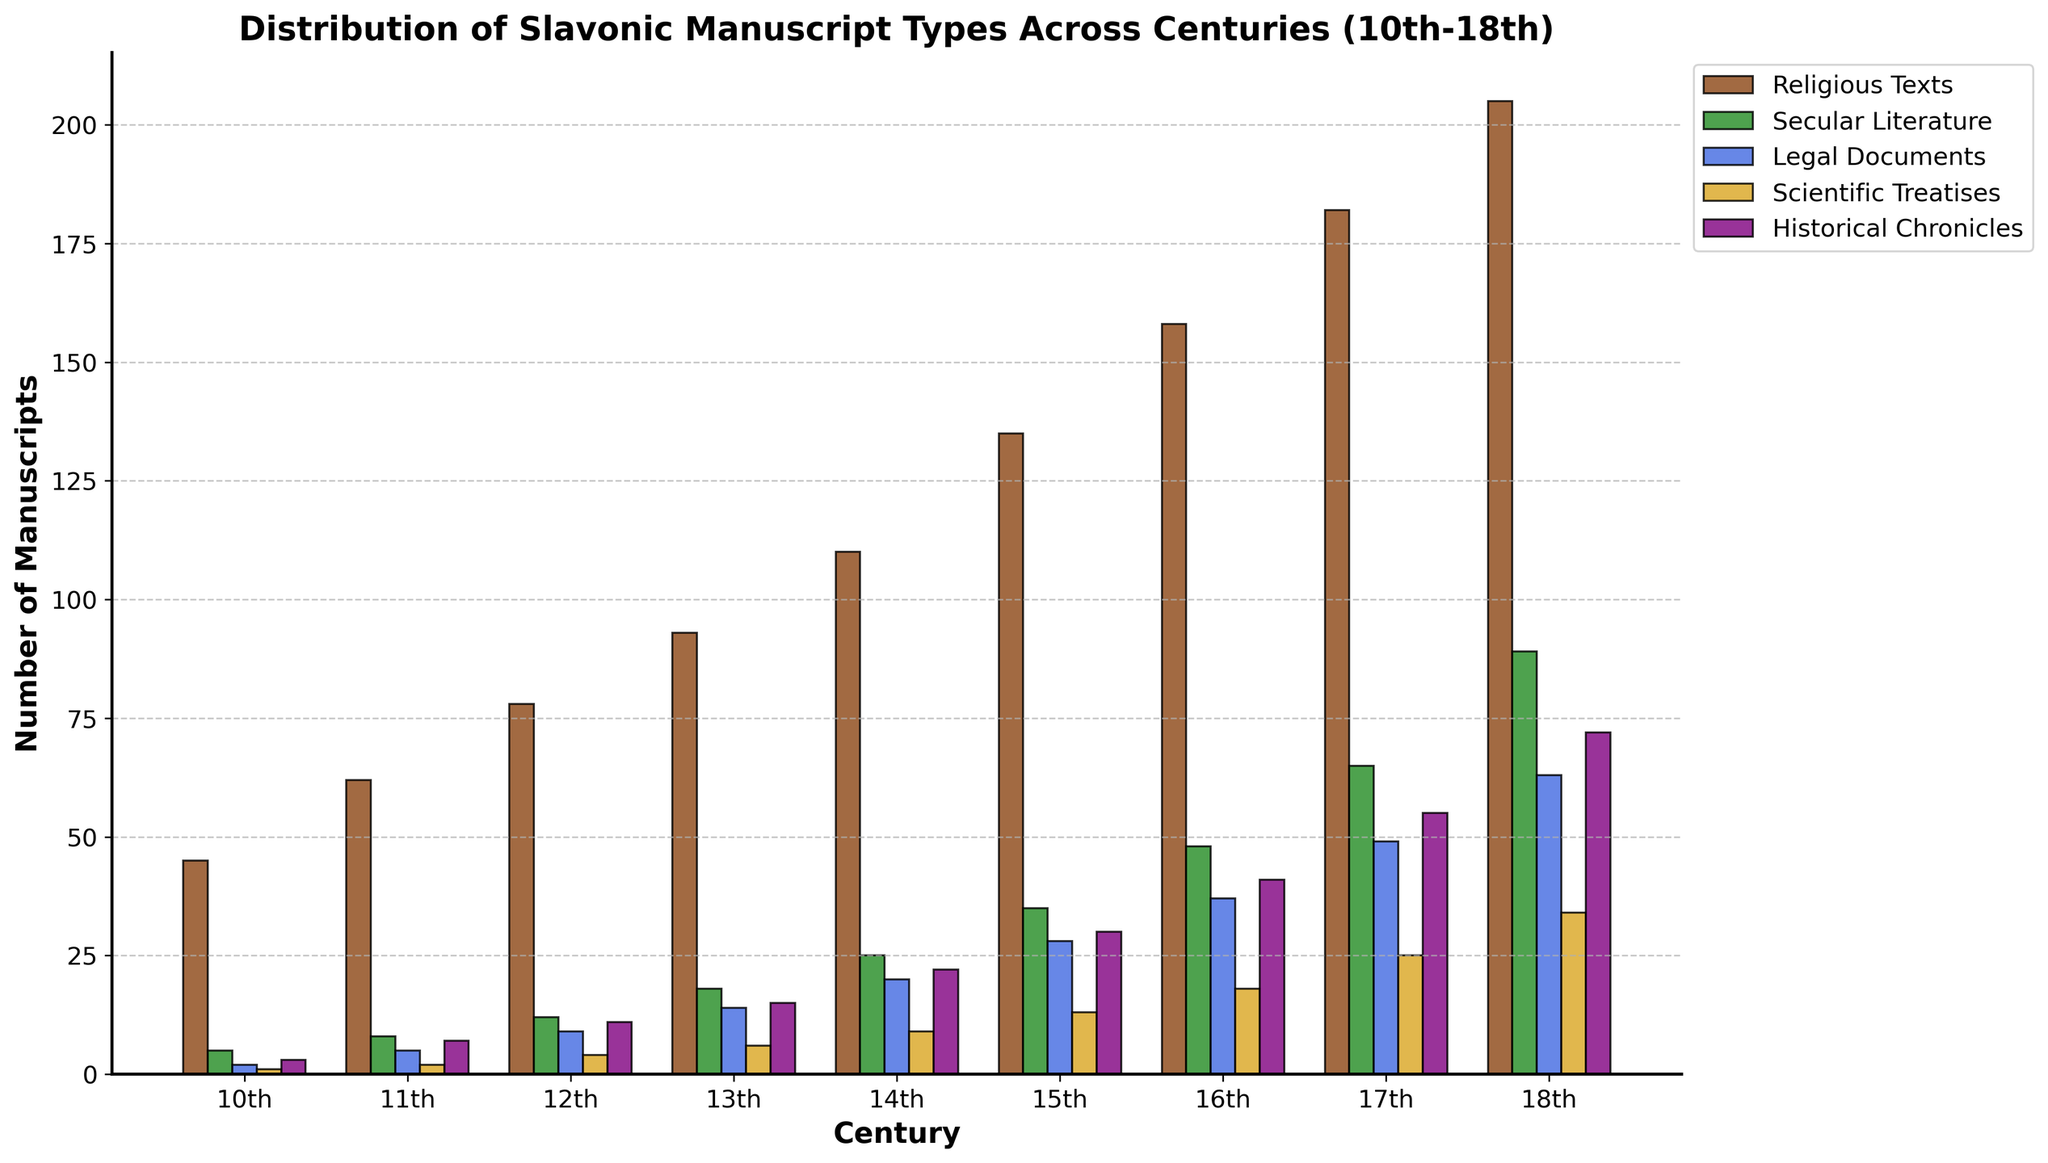Which century shows the highest number of Historical Chronicles? Look at the bars for Historical Chronicles, which are colored purple, and find the tallest one. The tallest bar is in the 18th century.
Answer: 18th century What's the total number of Religious Texts and Legal Documents in the 15th century? Sum the values for Religious Texts and Legal Documents in the 15th century: 135 (Religious Texts) + 28 (Legal Documents) = 163.
Answer: 163 In which century did Secular Literature surpass 40 manuscripts for the first time? Examine the green bars for Secular Literature and find the first century where the bar exceeds 40. It surpasses 40 in the 16th century with 48 manuscripts.
Answer: 16th century By how much did the number of Scientific Treatises increase from the 13th to the 18th century? Subtract the number of Scientific Treatises in the 13th century from that in the 18th century: 34 (18th century) - 6 (13th century) = 28.
Answer: 28 Which type of manuscript experienced the smallest increase from the 12th to the 13th century? Calculate the differences between the 12th and 13th centuries for each manuscript type: Religious Texts (93-78=15), Secular Literature (18-12=6), Legal Documents (14-9=5), Scientific Treatises (6-4=2), Historical Chronicles (15-11=4). The smallest increase is in Scientific Treatises with an increase of 2.
Answer: Scientific Treatises What is the average number of Religious Texts per century? Sum the values for Religious Texts across all centuries and divide by the number of centuries: (45 + 62 + 78 + 93 + 110 + 135 + 158 + 182 + 205) / 9 = 118.67 (rounded to two decimal places).
Answer: 118.67 In which century did Legal Documents grow the fastest compared to the previous century? Calculate the growths for Legal Documents across each century: 11th-10th (5-2=3), 12th-11th (9-5=4), 13th-12th (14-9=5), 14th-13th (20-14=6), 15th-14th (28-20=8), 16th-15th (37-28=9), 17th-16th (49-37=12), 18th-17th (63-49=14). The fastest growth was between the 17th and 18th centuries with an increase of 14.
Answer: 18th century Between which two manuscript types is there the largest difference in their counts in the 14th century, and what is that difference? Subtract the counts for each pair of manuscript types in the 14th century and find the largest difference: Religious Texts vs. Secular Literature (110-25=85), Religious Texts vs. Legal Documents (110-20=90), Religious Texts vs. Scientific Treatises (110-9=101), Religious Texts vs. Historical Chronicles (110-22=88), Secular Literature vs. Legal Documents (25-20=5), Secular Literature vs. Scientific Treatises (25-9=16), Secular Literature vs. Historical Chronicles (25-22=3), Legal Documents vs. Scientific Treatises (20-9=11), Legal Documents vs. Historical Chronicles (20-22=2), Scientific Treatises vs. Historical Chronicles (9-22=-13). The largest difference is between Religious Texts and Scientific Treatises, with a difference of 101.
Answer: Religious Texts and Scientific Treatises, 101 